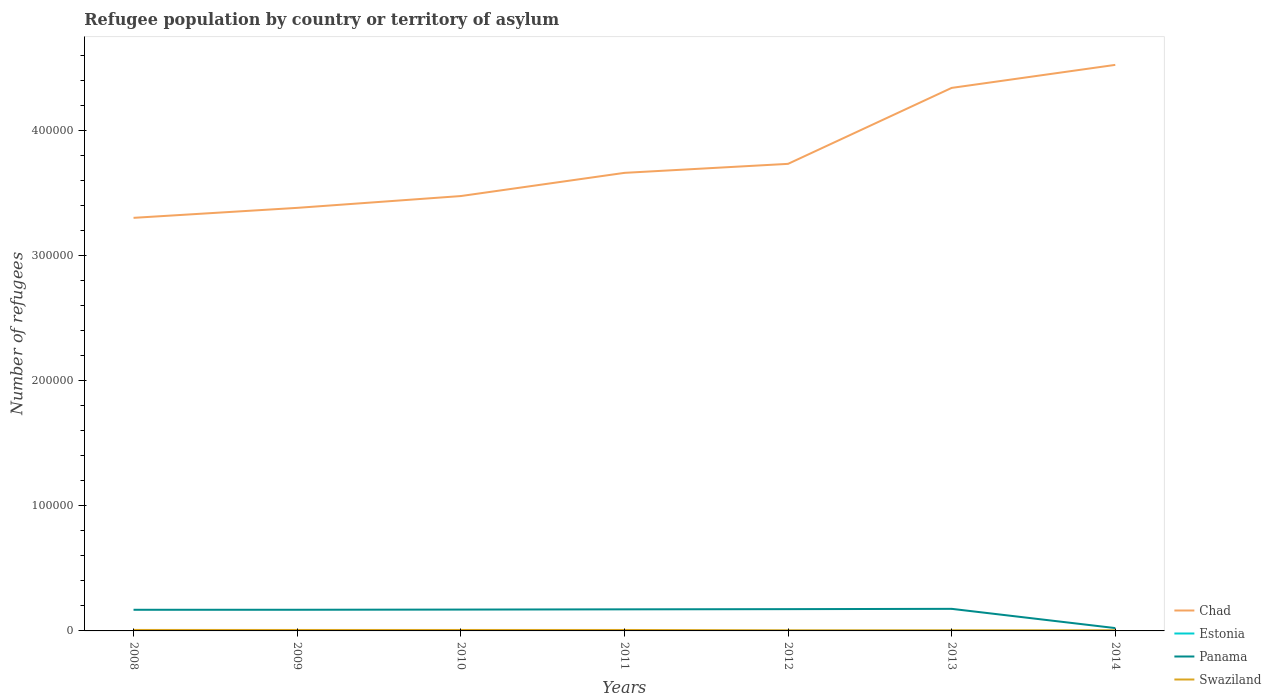How many different coloured lines are there?
Your answer should be compact. 4. What is the total number of refugees in Panama in the graph?
Give a very brief answer. 1.52e+04. What is the difference between the highest and the second highest number of refugees in Swaziland?
Your answer should be very brief. 270. What is the difference between the highest and the lowest number of refugees in Estonia?
Give a very brief answer. 3. Is the number of refugees in Swaziland strictly greater than the number of refugees in Chad over the years?
Give a very brief answer. Yes. How many lines are there?
Keep it short and to the point. 4. How many years are there in the graph?
Keep it short and to the point. 7. What is the difference between two consecutive major ticks on the Y-axis?
Keep it short and to the point. 1.00e+05. What is the title of the graph?
Give a very brief answer. Refugee population by country or territory of asylum. Does "Indonesia" appear as one of the legend labels in the graph?
Your answer should be very brief. No. What is the label or title of the Y-axis?
Your response must be concise. Number of refugees. What is the Number of refugees of Chad in 2008?
Make the answer very short. 3.31e+05. What is the Number of refugees of Panama in 2008?
Provide a succinct answer. 1.69e+04. What is the Number of refugees in Swaziland in 2008?
Give a very brief answer. 775. What is the Number of refugees in Chad in 2009?
Provide a short and direct response. 3.38e+05. What is the Number of refugees in Panama in 2009?
Your response must be concise. 1.69e+04. What is the Number of refugees in Swaziland in 2009?
Ensure brevity in your answer.  759. What is the Number of refugees in Chad in 2010?
Your answer should be compact. 3.48e+05. What is the Number of refugees of Estonia in 2010?
Your answer should be compact. 39. What is the Number of refugees in Panama in 2010?
Offer a terse response. 1.71e+04. What is the Number of refugees of Swaziland in 2010?
Make the answer very short. 759. What is the Number of refugees in Chad in 2011?
Make the answer very short. 3.66e+05. What is the Number of refugees in Estonia in 2011?
Give a very brief answer. 50. What is the Number of refugees in Panama in 2011?
Your answer should be very brief. 1.73e+04. What is the Number of refugees of Swaziland in 2011?
Your answer should be compact. 759. What is the Number of refugees of Chad in 2012?
Provide a succinct answer. 3.74e+05. What is the Number of refugees in Estonia in 2012?
Your answer should be compact. 63. What is the Number of refugees in Panama in 2012?
Ensure brevity in your answer.  1.74e+04. What is the Number of refugees of Swaziland in 2012?
Provide a succinct answer. 505. What is the Number of refugees of Chad in 2013?
Offer a terse response. 4.34e+05. What is the Number of refugees of Estonia in 2013?
Give a very brief answer. 70. What is the Number of refugees of Panama in 2013?
Give a very brief answer. 1.77e+04. What is the Number of refugees in Swaziland in 2013?
Your response must be concise. 507. What is the Number of refugees in Chad in 2014?
Ensure brevity in your answer.  4.53e+05. What is the Number of refugees of Estonia in 2014?
Keep it short and to the point. 90. What is the Number of refugees of Panama in 2014?
Provide a succinct answer. 2271. What is the Number of refugees in Swaziland in 2014?
Make the answer very short. 515. Across all years, what is the maximum Number of refugees in Chad?
Provide a succinct answer. 4.53e+05. Across all years, what is the maximum Number of refugees in Panama?
Your answer should be very brief. 1.77e+04. Across all years, what is the maximum Number of refugees of Swaziland?
Keep it short and to the point. 775. Across all years, what is the minimum Number of refugees of Chad?
Give a very brief answer. 3.31e+05. Across all years, what is the minimum Number of refugees of Panama?
Your answer should be very brief. 2271. Across all years, what is the minimum Number of refugees of Swaziland?
Give a very brief answer. 505. What is the total Number of refugees of Chad in the graph?
Keep it short and to the point. 2.64e+06. What is the total Number of refugees of Estonia in the graph?
Offer a very short reply. 358. What is the total Number of refugees in Panama in the graph?
Provide a succinct answer. 1.06e+05. What is the total Number of refugees of Swaziland in the graph?
Make the answer very short. 4579. What is the difference between the Number of refugees of Chad in 2008 and that in 2009?
Your answer should be very brief. -7985. What is the difference between the Number of refugees of Estonia in 2008 and that in 2009?
Ensure brevity in your answer.  -2. What is the difference between the Number of refugees of Panama in 2008 and that in 2009?
Ensure brevity in your answer.  -10. What is the difference between the Number of refugees in Chad in 2008 and that in 2010?
Offer a terse response. -1.74e+04. What is the difference between the Number of refugees of Estonia in 2008 and that in 2010?
Your response must be concise. -17. What is the difference between the Number of refugees in Panama in 2008 and that in 2010?
Keep it short and to the point. -160. What is the difference between the Number of refugees in Chad in 2008 and that in 2011?
Your answer should be very brief. -3.60e+04. What is the difference between the Number of refugees of Estonia in 2008 and that in 2011?
Give a very brief answer. -28. What is the difference between the Number of refugees in Panama in 2008 and that in 2011?
Offer a very short reply. -349. What is the difference between the Number of refugees in Swaziland in 2008 and that in 2011?
Make the answer very short. 16. What is the difference between the Number of refugees in Chad in 2008 and that in 2012?
Your response must be concise. -4.32e+04. What is the difference between the Number of refugees of Estonia in 2008 and that in 2012?
Make the answer very short. -41. What is the difference between the Number of refugees in Panama in 2008 and that in 2012?
Your response must be concise. -516. What is the difference between the Number of refugees in Swaziland in 2008 and that in 2012?
Offer a terse response. 270. What is the difference between the Number of refugees of Chad in 2008 and that in 2013?
Provide a succinct answer. -1.04e+05. What is the difference between the Number of refugees in Estonia in 2008 and that in 2013?
Keep it short and to the point. -48. What is the difference between the Number of refugees in Panama in 2008 and that in 2013?
Keep it short and to the point. -752. What is the difference between the Number of refugees of Swaziland in 2008 and that in 2013?
Offer a very short reply. 268. What is the difference between the Number of refugees of Chad in 2008 and that in 2014?
Offer a very short reply. -1.22e+05. What is the difference between the Number of refugees in Estonia in 2008 and that in 2014?
Provide a short and direct response. -68. What is the difference between the Number of refugees of Panama in 2008 and that in 2014?
Provide a succinct answer. 1.46e+04. What is the difference between the Number of refugees of Swaziland in 2008 and that in 2014?
Provide a succinct answer. 260. What is the difference between the Number of refugees of Chad in 2009 and that in 2010?
Provide a short and direct response. -9444. What is the difference between the Number of refugees in Estonia in 2009 and that in 2010?
Provide a short and direct response. -15. What is the difference between the Number of refugees of Panama in 2009 and that in 2010?
Provide a succinct answer. -150. What is the difference between the Number of refugees in Swaziland in 2009 and that in 2010?
Keep it short and to the point. 0. What is the difference between the Number of refugees in Chad in 2009 and that in 2011?
Provide a short and direct response. -2.80e+04. What is the difference between the Number of refugees of Panama in 2009 and that in 2011?
Provide a short and direct response. -339. What is the difference between the Number of refugees in Chad in 2009 and that in 2012?
Offer a very short reply. -3.52e+04. What is the difference between the Number of refugees of Estonia in 2009 and that in 2012?
Provide a succinct answer. -39. What is the difference between the Number of refugees in Panama in 2009 and that in 2012?
Provide a succinct answer. -506. What is the difference between the Number of refugees of Swaziland in 2009 and that in 2012?
Ensure brevity in your answer.  254. What is the difference between the Number of refugees of Chad in 2009 and that in 2013?
Make the answer very short. -9.60e+04. What is the difference between the Number of refugees of Estonia in 2009 and that in 2013?
Your answer should be very brief. -46. What is the difference between the Number of refugees in Panama in 2009 and that in 2013?
Provide a short and direct response. -742. What is the difference between the Number of refugees of Swaziland in 2009 and that in 2013?
Your response must be concise. 252. What is the difference between the Number of refugees in Chad in 2009 and that in 2014?
Make the answer very short. -1.14e+05. What is the difference between the Number of refugees of Estonia in 2009 and that in 2014?
Your response must be concise. -66. What is the difference between the Number of refugees in Panama in 2009 and that in 2014?
Your response must be concise. 1.47e+04. What is the difference between the Number of refugees of Swaziland in 2009 and that in 2014?
Your answer should be compact. 244. What is the difference between the Number of refugees of Chad in 2010 and that in 2011?
Your answer should be very brief. -1.86e+04. What is the difference between the Number of refugees in Estonia in 2010 and that in 2011?
Ensure brevity in your answer.  -11. What is the difference between the Number of refugees of Panama in 2010 and that in 2011?
Your answer should be very brief. -189. What is the difference between the Number of refugees in Chad in 2010 and that in 2012?
Keep it short and to the point. -2.58e+04. What is the difference between the Number of refugees of Estonia in 2010 and that in 2012?
Your answer should be compact. -24. What is the difference between the Number of refugees in Panama in 2010 and that in 2012?
Provide a succinct answer. -356. What is the difference between the Number of refugees of Swaziland in 2010 and that in 2012?
Provide a short and direct response. 254. What is the difference between the Number of refugees of Chad in 2010 and that in 2013?
Give a very brief answer. -8.65e+04. What is the difference between the Number of refugees in Estonia in 2010 and that in 2013?
Your response must be concise. -31. What is the difference between the Number of refugees in Panama in 2010 and that in 2013?
Your answer should be very brief. -592. What is the difference between the Number of refugees in Swaziland in 2010 and that in 2013?
Make the answer very short. 252. What is the difference between the Number of refugees in Chad in 2010 and that in 2014?
Provide a short and direct response. -1.05e+05. What is the difference between the Number of refugees of Estonia in 2010 and that in 2014?
Your answer should be very brief. -51. What is the difference between the Number of refugees in Panama in 2010 and that in 2014?
Make the answer very short. 1.48e+04. What is the difference between the Number of refugees in Swaziland in 2010 and that in 2014?
Provide a succinct answer. 244. What is the difference between the Number of refugees in Chad in 2011 and that in 2012?
Offer a very short reply. -7201. What is the difference between the Number of refugees of Panama in 2011 and that in 2012?
Your answer should be compact. -167. What is the difference between the Number of refugees of Swaziland in 2011 and that in 2012?
Ensure brevity in your answer.  254. What is the difference between the Number of refugees in Chad in 2011 and that in 2013?
Make the answer very short. -6.80e+04. What is the difference between the Number of refugees in Estonia in 2011 and that in 2013?
Provide a short and direct response. -20. What is the difference between the Number of refugees of Panama in 2011 and that in 2013?
Keep it short and to the point. -403. What is the difference between the Number of refugees of Swaziland in 2011 and that in 2013?
Give a very brief answer. 252. What is the difference between the Number of refugees of Chad in 2011 and that in 2014?
Ensure brevity in your answer.  -8.64e+04. What is the difference between the Number of refugees in Panama in 2011 and that in 2014?
Ensure brevity in your answer.  1.50e+04. What is the difference between the Number of refugees of Swaziland in 2011 and that in 2014?
Your answer should be very brief. 244. What is the difference between the Number of refugees in Chad in 2012 and that in 2013?
Keep it short and to the point. -6.08e+04. What is the difference between the Number of refugees of Estonia in 2012 and that in 2013?
Give a very brief answer. -7. What is the difference between the Number of refugees in Panama in 2012 and that in 2013?
Ensure brevity in your answer.  -236. What is the difference between the Number of refugees of Chad in 2012 and that in 2014?
Keep it short and to the point. -7.92e+04. What is the difference between the Number of refugees of Estonia in 2012 and that in 2014?
Make the answer very short. -27. What is the difference between the Number of refugees of Panama in 2012 and that in 2014?
Keep it short and to the point. 1.52e+04. What is the difference between the Number of refugees of Chad in 2013 and that in 2014?
Keep it short and to the point. -1.84e+04. What is the difference between the Number of refugees of Estonia in 2013 and that in 2014?
Your response must be concise. -20. What is the difference between the Number of refugees in Panama in 2013 and that in 2014?
Provide a short and direct response. 1.54e+04. What is the difference between the Number of refugees of Swaziland in 2013 and that in 2014?
Provide a succinct answer. -8. What is the difference between the Number of refugees of Chad in 2008 and the Number of refugees of Estonia in 2009?
Offer a very short reply. 3.30e+05. What is the difference between the Number of refugees of Chad in 2008 and the Number of refugees of Panama in 2009?
Keep it short and to the point. 3.14e+05. What is the difference between the Number of refugees of Chad in 2008 and the Number of refugees of Swaziland in 2009?
Provide a succinct answer. 3.30e+05. What is the difference between the Number of refugees in Estonia in 2008 and the Number of refugees in Panama in 2009?
Provide a short and direct response. -1.69e+04. What is the difference between the Number of refugees of Estonia in 2008 and the Number of refugees of Swaziland in 2009?
Ensure brevity in your answer.  -737. What is the difference between the Number of refugees in Panama in 2008 and the Number of refugees in Swaziland in 2009?
Make the answer very short. 1.62e+04. What is the difference between the Number of refugees in Chad in 2008 and the Number of refugees in Estonia in 2010?
Make the answer very short. 3.30e+05. What is the difference between the Number of refugees in Chad in 2008 and the Number of refugees in Panama in 2010?
Your answer should be very brief. 3.13e+05. What is the difference between the Number of refugees of Chad in 2008 and the Number of refugees of Swaziland in 2010?
Make the answer very short. 3.30e+05. What is the difference between the Number of refugees in Estonia in 2008 and the Number of refugees in Panama in 2010?
Your answer should be very brief. -1.71e+04. What is the difference between the Number of refugees of Estonia in 2008 and the Number of refugees of Swaziland in 2010?
Ensure brevity in your answer.  -737. What is the difference between the Number of refugees of Panama in 2008 and the Number of refugees of Swaziland in 2010?
Give a very brief answer. 1.62e+04. What is the difference between the Number of refugees in Chad in 2008 and the Number of refugees in Estonia in 2011?
Offer a terse response. 3.30e+05. What is the difference between the Number of refugees of Chad in 2008 and the Number of refugees of Panama in 2011?
Provide a succinct answer. 3.13e+05. What is the difference between the Number of refugees in Chad in 2008 and the Number of refugees in Swaziland in 2011?
Provide a short and direct response. 3.30e+05. What is the difference between the Number of refugees in Estonia in 2008 and the Number of refugees in Panama in 2011?
Your answer should be compact. -1.72e+04. What is the difference between the Number of refugees of Estonia in 2008 and the Number of refugees of Swaziland in 2011?
Give a very brief answer. -737. What is the difference between the Number of refugees of Panama in 2008 and the Number of refugees of Swaziland in 2011?
Provide a short and direct response. 1.62e+04. What is the difference between the Number of refugees in Chad in 2008 and the Number of refugees in Estonia in 2012?
Your response must be concise. 3.30e+05. What is the difference between the Number of refugees in Chad in 2008 and the Number of refugees in Panama in 2012?
Your answer should be very brief. 3.13e+05. What is the difference between the Number of refugees in Chad in 2008 and the Number of refugees in Swaziland in 2012?
Offer a very short reply. 3.30e+05. What is the difference between the Number of refugees of Estonia in 2008 and the Number of refugees of Panama in 2012?
Provide a succinct answer. -1.74e+04. What is the difference between the Number of refugees of Estonia in 2008 and the Number of refugees of Swaziland in 2012?
Ensure brevity in your answer.  -483. What is the difference between the Number of refugees in Panama in 2008 and the Number of refugees in Swaziland in 2012?
Your answer should be compact. 1.64e+04. What is the difference between the Number of refugees of Chad in 2008 and the Number of refugees of Estonia in 2013?
Provide a succinct answer. 3.30e+05. What is the difference between the Number of refugees in Chad in 2008 and the Number of refugees in Panama in 2013?
Your answer should be compact. 3.13e+05. What is the difference between the Number of refugees in Chad in 2008 and the Number of refugees in Swaziland in 2013?
Keep it short and to the point. 3.30e+05. What is the difference between the Number of refugees of Estonia in 2008 and the Number of refugees of Panama in 2013?
Keep it short and to the point. -1.76e+04. What is the difference between the Number of refugees in Estonia in 2008 and the Number of refugees in Swaziland in 2013?
Your answer should be compact. -485. What is the difference between the Number of refugees in Panama in 2008 and the Number of refugees in Swaziland in 2013?
Your response must be concise. 1.64e+04. What is the difference between the Number of refugees of Chad in 2008 and the Number of refugees of Estonia in 2014?
Your answer should be very brief. 3.30e+05. What is the difference between the Number of refugees in Chad in 2008 and the Number of refugees in Panama in 2014?
Ensure brevity in your answer.  3.28e+05. What is the difference between the Number of refugees of Chad in 2008 and the Number of refugees of Swaziland in 2014?
Provide a succinct answer. 3.30e+05. What is the difference between the Number of refugees in Estonia in 2008 and the Number of refugees in Panama in 2014?
Keep it short and to the point. -2249. What is the difference between the Number of refugees in Estonia in 2008 and the Number of refugees in Swaziland in 2014?
Make the answer very short. -493. What is the difference between the Number of refugees in Panama in 2008 and the Number of refugees in Swaziland in 2014?
Your answer should be very brief. 1.64e+04. What is the difference between the Number of refugees of Chad in 2009 and the Number of refugees of Estonia in 2010?
Offer a terse response. 3.38e+05. What is the difference between the Number of refugees in Chad in 2009 and the Number of refugees in Panama in 2010?
Keep it short and to the point. 3.21e+05. What is the difference between the Number of refugees in Chad in 2009 and the Number of refugees in Swaziland in 2010?
Provide a short and direct response. 3.38e+05. What is the difference between the Number of refugees in Estonia in 2009 and the Number of refugees in Panama in 2010?
Offer a terse response. -1.70e+04. What is the difference between the Number of refugees in Estonia in 2009 and the Number of refugees in Swaziland in 2010?
Offer a very short reply. -735. What is the difference between the Number of refugees of Panama in 2009 and the Number of refugees of Swaziland in 2010?
Provide a short and direct response. 1.62e+04. What is the difference between the Number of refugees in Chad in 2009 and the Number of refugees in Estonia in 2011?
Ensure brevity in your answer.  3.38e+05. What is the difference between the Number of refugees of Chad in 2009 and the Number of refugees of Panama in 2011?
Offer a very short reply. 3.21e+05. What is the difference between the Number of refugees in Chad in 2009 and the Number of refugees in Swaziland in 2011?
Provide a succinct answer. 3.38e+05. What is the difference between the Number of refugees of Estonia in 2009 and the Number of refugees of Panama in 2011?
Offer a very short reply. -1.72e+04. What is the difference between the Number of refugees in Estonia in 2009 and the Number of refugees in Swaziland in 2011?
Provide a short and direct response. -735. What is the difference between the Number of refugees in Panama in 2009 and the Number of refugees in Swaziland in 2011?
Give a very brief answer. 1.62e+04. What is the difference between the Number of refugees of Chad in 2009 and the Number of refugees of Estonia in 2012?
Provide a short and direct response. 3.38e+05. What is the difference between the Number of refugees of Chad in 2009 and the Number of refugees of Panama in 2012?
Keep it short and to the point. 3.21e+05. What is the difference between the Number of refugees in Chad in 2009 and the Number of refugees in Swaziland in 2012?
Ensure brevity in your answer.  3.38e+05. What is the difference between the Number of refugees in Estonia in 2009 and the Number of refugees in Panama in 2012?
Ensure brevity in your answer.  -1.74e+04. What is the difference between the Number of refugees in Estonia in 2009 and the Number of refugees in Swaziland in 2012?
Your answer should be very brief. -481. What is the difference between the Number of refugees of Panama in 2009 and the Number of refugees of Swaziland in 2012?
Make the answer very short. 1.64e+04. What is the difference between the Number of refugees in Chad in 2009 and the Number of refugees in Estonia in 2013?
Your answer should be very brief. 3.38e+05. What is the difference between the Number of refugees in Chad in 2009 and the Number of refugees in Panama in 2013?
Your answer should be compact. 3.21e+05. What is the difference between the Number of refugees in Chad in 2009 and the Number of refugees in Swaziland in 2013?
Keep it short and to the point. 3.38e+05. What is the difference between the Number of refugees in Estonia in 2009 and the Number of refugees in Panama in 2013?
Ensure brevity in your answer.  -1.76e+04. What is the difference between the Number of refugees in Estonia in 2009 and the Number of refugees in Swaziland in 2013?
Give a very brief answer. -483. What is the difference between the Number of refugees of Panama in 2009 and the Number of refugees of Swaziland in 2013?
Offer a terse response. 1.64e+04. What is the difference between the Number of refugees of Chad in 2009 and the Number of refugees of Estonia in 2014?
Provide a short and direct response. 3.38e+05. What is the difference between the Number of refugees of Chad in 2009 and the Number of refugees of Panama in 2014?
Make the answer very short. 3.36e+05. What is the difference between the Number of refugees of Chad in 2009 and the Number of refugees of Swaziland in 2014?
Ensure brevity in your answer.  3.38e+05. What is the difference between the Number of refugees of Estonia in 2009 and the Number of refugees of Panama in 2014?
Your answer should be very brief. -2247. What is the difference between the Number of refugees in Estonia in 2009 and the Number of refugees in Swaziland in 2014?
Keep it short and to the point. -491. What is the difference between the Number of refugees in Panama in 2009 and the Number of refugees in Swaziland in 2014?
Your answer should be very brief. 1.64e+04. What is the difference between the Number of refugees of Chad in 2010 and the Number of refugees of Estonia in 2011?
Your response must be concise. 3.48e+05. What is the difference between the Number of refugees of Chad in 2010 and the Number of refugees of Panama in 2011?
Offer a terse response. 3.31e+05. What is the difference between the Number of refugees of Chad in 2010 and the Number of refugees of Swaziland in 2011?
Make the answer very short. 3.47e+05. What is the difference between the Number of refugees in Estonia in 2010 and the Number of refugees in Panama in 2011?
Offer a very short reply. -1.72e+04. What is the difference between the Number of refugees in Estonia in 2010 and the Number of refugees in Swaziland in 2011?
Offer a terse response. -720. What is the difference between the Number of refugees in Panama in 2010 and the Number of refugees in Swaziland in 2011?
Offer a very short reply. 1.63e+04. What is the difference between the Number of refugees of Chad in 2010 and the Number of refugees of Estonia in 2012?
Provide a succinct answer. 3.48e+05. What is the difference between the Number of refugees of Chad in 2010 and the Number of refugees of Panama in 2012?
Make the answer very short. 3.31e+05. What is the difference between the Number of refugees in Chad in 2010 and the Number of refugees in Swaziland in 2012?
Ensure brevity in your answer.  3.47e+05. What is the difference between the Number of refugees in Estonia in 2010 and the Number of refugees in Panama in 2012?
Offer a terse response. -1.74e+04. What is the difference between the Number of refugees of Estonia in 2010 and the Number of refugees of Swaziland in 2012?
Your answer should be very brief. -466. What is the difference between the Number of refugees in Panama in 2010 and the Number of refugees in Swaziland in 2012?
Offer a terse response. 1.66e+04. What is the difference between the Number of refugees in Chad in 2010 and the Number of refugees in Estonia in 2013?
Give a very brief answer. 3.48e+05. What is the difference between the Number of refugees in Chad in 2010 and the Number of refugees in Panama in 2013?
Provide a short and direct response. 3.30e+05. What is the difference between the Number of refugees of Chad in 2010 and the Number of refugees of Swaziland in 2013?
Your answer should be very brief. 3.47e+05. What is the difference between the Number of refugees of Estonia in 2010 and the Number of refugees of Panama in 2013?
Provide a short and direct response. -1.76e+04. What is the difference between the Number of refugees of Estonia in 2010 and the Number of refugees of Swaziland in 2013?
Your response must be concise. -468. What is the difference between the Number of refugees of Panama in 2010 and the Number of refugees of Swaziland in 2013?
Provide a succinct answer. 1.66e+04. What is the difference between the Number of refugees in Chad in 2010 and the Number of refugees in Estonia in 2014?
Ensure brevity in your answer.  3.48e+05. What is the difference between the Number of refugees in Chad in 2010 and the Number of refugees in Panama in 2014?
Provide a short and direct response. 3.46e+05. What is the difference between the Number of refugees in Chad in 2010 and the Number of refugees in Swaziland in 2014?
Your response must be concise. 3.47e+05. What is the difference between the Number of refugees in Estonia in 2010 and the Number of refugees in Panama in 2014?
Provide a short and direct response. -2232. What is the difference between the Number of refugees of Estonia in 2010 and the Number of refugees of Swaziland in 2014?
Your answer should be very brief. -476. What is the difference between the Number of refugees in Panama in 2010 and the Number of refugees in Swaziland in 2014?
Your answer should be compact. 1.66e+04. What is the difference between the Number of refugees in Chad in 2011 and the Number of refugees in Estonia in 2012?
Your response must be concise. 3.66e+05. What is the difference between the Number of refugees of Chad in 2011 and the Number of refugees of Panama in 2012?
Provide a short and direct response. 3.49e+05. What is the difference between the Number of refugees in Chad in 2011 and the Number of refugees in Swaziland in 2012?
Offer a terse response. 3.66e+05. What is the difference between the Number of refugees in Estonia in 2011 and the Number of refugees in Panama in 2012?
Your response must be concise. -1.74e+04. What is the difference between the Number of refugees in Estonia in 2011 and the Number of refugees in Swaziland in 2012?
Provide a succinct answer. -455. What is the difference between the Number of refugees of Panama in 2011 and the Number of refugees of Swaziland in 2012?
Give a very brief answer. 1.68e+04. What is the difference between the Number of refugees of Chad in 2011 and the Number of refugees of Estonia in 2013?
Keep it short and to the point. 3.66e+05. What is the difference between the Number of refugees in Chad in 2011 and the Number of refugees in Panama in 2013?
Provide a succinct answer. 3.49e+05. What is the difference between the Number of refugees of Chad in 2011 and the Number of refugees of Swaziland in 2013?
Give a very brief answer. 3.66e+05. What is the difference between the Number of refugees of Estonia in 2011 and the Number of refugees of Panama in 2013?
Your answer should be compact. -1.76e+04. What is the difference between the Number of refugees in Estonia in 2011 and the Number of refugees in Swaziland in 2013?
Ensure brevity in your answer.  -457. What is the difference between the Number of refugees in Panama in 2011 and the Number of refugees in Swaziland in 2013?
Your response must be concise. 1.68e+04. What is the difference between the Number of refugees in Chad in 2011 and the Number of refugees in Estonia in 2014?
Make the answer very short. 3.66e+05. What is the difference between the Number of refugees of Chad in 2011 and the Number of refugees of Panama in 2014?
Provide a succinct answer. 3.64e+05. What is the difference between the Number of refugees of Chad in 2011 and the Number of refugees of Swaziland in 2014?
Make the answer very short. 3.66e+05. What is the difference between the Number of refugees in Estonia in 2011 and the Number of refugees in Panama in 2014?
Offer a terse response. -2221. What is the difference between the Number of refugees of Estonia in 2011 and the Number of refugees of Swaziland in 2014?
Make the answer very short. -465. What is the difference between the Number of refugees in Panama in 2011 and the Number of refugees in Swaziland in 2014?
Offer a terse response. 1.67e+04. What is the difference between the Number of refugees in Chad in 2012 and the Number of refugees in Estonia in 2013?
Provide a short and direct response. 3.74e+05. What is the difference between the Number of refugees of Chad in 2012 and the Number of refugees of Panama in 2013?
Provide a short and direct response. 3.56e+05. What is the difference between the Number of refugees in Chad in 2012 and the Number of refugees in Swaziland in 2013?
Offer a terse response. 3.73e+05. What is the difference between the Number of refugees of Estonia in 2012 and the Number of refugees of Panama in 2013?
Keep it short and to the point. -1.76e+04. What is the difference between the Number of refugees of Estonia in 2012 and the Number of refugees of Swaziland in 2013?
Ensure brevity in your answer.  -444. What is the difference between the Number of refugees of Panama in 2012 and the Number of refugees of Swaziland in 2013?
Ensure brevity in your answer.  1.69e+04. What is the difference between the Number of refugees of Chad in 2012 and the Number of refugees of Estonia in 2014?
Your response must be concise. 3.74e+05. What is the difference between the Number of refugees in Chad in 2012 and the Number of refugees in Panama in 2014?
Provide a short and direct response. 3.71e+05. What is the difference between the Number of refugees of Chad in 2012 and the Number of refugees of Swaziland in 2014?
Your answer should be very brief. 3.73e+05. What is the difference between the Number of refugees of Estonia in 2012 and the Number of refugees of Panama in 2014?
Offer a terse response. -2208. What is the difference between the Number of refugees in Estonia in 2012 and the Number of refugees in Swaziland in 2014?
Your response must be concise. -452. What is the difference between the Number of refugees of Panama in 2012 and the Number of refugees of Swaziland in 2014?
Make the answer very short. 1.69e+04. What is the difference between the Number of refugees of Chad in 2013 and the Number of refugees of Estonia in 2014?
Offer a terse response. 4.34e+05. What is the difference between the Number of refugees in Chad in 2013 and the Number of refugees in Panama in 2014?
Ensure brevity in your answer.  4.32e+05. What is the difference between the Number of refugees in Chad in 2013 and the Number of refugees in Swaziland in 2014?
Make the answer very short. 4.34e+05. What is the difference between the Number of refugees of Estonia in 2013 and the Number of refugees of Panama in 2014?
Provide a short and direct response. -2201. What is the difference between the Number of refugees of Estonia in 2013 and the Number of refugees of Swaziland in 2014?
Your answer should be compact. -445. What is the difference between the Number of refugees of Panama in 2013 and the Number of refugees of Swaziland in 2014?
Your answer should be very brief. 1.72e+04. What is the average Number of refugees of Chad per year?
Ensure brevity in your answer.  3.78e+05. What is the average Number of refugees of Estonia per year?
Provide a succinct answer. 51.14. What is the average Number of refugees in Panama per year?
Your answer should be very brief. 1.51e+04. What is the average Number of refugees in Swaziland per year?
Provide a short and direct response. 654.14. In the year 2008, what is the difference between the Number of refugees in Chad and Number of refugees in Estonia?
Give a very brief answer. 3.30e+05. In the year 2008, what is the difference between the Number of refugees in Chad and Number of refugees in Panama?
Provide a succinct answer. 3.14e+05. In the year 2008, what is the difference between the Number of refugees of Chad and Number of refugees of Swaziland?
Ensure brevity in your answer.  3.30e+05. In the year 2008, what is the difference between the Number of refugees in Estonia and Number of refugees in Panama?
Make the answer very short. -1.69e+04. In the year 2008, what is the difference between the Number of refugees in Estonia and Number of refugees in Swaziland?
Give a very brief answer. -753. In the year 2008, what is the difference between the Number of refugees in Panama and Number of refugees in Swaziland?
Offer a terse response. 1.61e+04. In the year 2009, what is the difference between the Number of refugees of Chad and Number of refugees of Estonia?
Offer a terse response. 3.38e+05. In the year 2009, what is the difference between the Number of refugees in Chad and Number of refugees in Panama?
Give a very brief answer. 3.22e+05. In the year 2009, what is the difference between the Number of refugees in Chad and Number of refugees in Swaziland?
Your response must be concise. 3.38e+05. In the year 2009, what is the difference between the Number of refugees in Estonia and Number of refugees in Panama?
Make the answer very short. -1.69e+04. In the year 2009, what is the difference between the Number of refugees of Estonia and Number of refugees of Swaziland?
Offer a very short reply. -735. In the year 2009, what is the difference between the Number of refugees in Panama and Number of refugees in Swaziland?
Offer a very short reply. 1.62e+04. In the year 2010, what is the difference between the Number of refugees of Chad and Number of refugees of Estonia?
Your answer should be very brief. 3.48e+05. In the year 2010, what is the difference between the Number of refugees of Chad and Number of refugees of Panama?
Provide a succinct answer. 3.31e+05. In the year 2010, what is the difference between the Number of refugees in Chad and Number of refugees in Swaziland?
Ensure brevity in your answer.  3.47e+05. In the year 2010, what is the difference between the Number of refugees in Estonia and Number of refugees in Panama?
Keep it short and to the point. -1.70e+04. In the year 2010, what is the difference between the Number of refugees in Estonia and Number of refugees in Swaziland?
Your answer should be compact. -720. In the year 2010, what is the difference between the Number of refugees of Panama and Number of refugees of Swaziland?
Offer a very short reply. 1.63e+04. In the year 2011, what is the difference between the Number of refugees of Chad and Number of refugees of Estonia?
Give a very brief answer. 3.66e+05. In the year 2011, what is the difference between the Number of refugees in Chad and Number of refugees in Panama?
Provide a short and direct response. 3.49e+05. In the year 2011, what is the difference between the Number of refugees in Chad and Number of refugees in Swaziland?
Provide a succinct answer. 3.66e+05. In the year 2011, what is the difference between the Number of refugees in Estonia and Number of refugees in Panama?
Offer a very short reply. -1.72e+04. In the year 2011, what is the difference between the Number of refugees in Estonia and Number of refugees in Swaziland?
Your response must be concise. -709. In the year 2011, what is the difference between the Number of refugees of Panama and Number of refugees of Swaziland?
Keep it short and to the point. 1.65e+04. In the year 2012, what is the difference between the Number of refugees of Chad and Number of refugees of Estonia?
Your response must be concise. 3.74e+05. In the year 2012, what is the difference between the Number of refugees of Chad and Number of refugees of Panama?
Provide a succinct answer. 3.56e+05. In the year 2012, what is the difference between the Number of refugees in Chad and Number of refugees in Swaziland?
Provide a short and direct response. 3.73e+05. In the year 2012, what is the difference between the Number of refugees of Estonia and Number of refugees of Panama?
Give a very brief answer. -1.74e+04. In the year 2012, what is the difference between the Number of refugees in Estonia and Number of refugees in Swaziland?
Provide a short and direct response. -442. In the year 2012, what is the difference between the Number of refugees of Panama and Number of refugees of Swaziland?
Provide a short and direct response. 1.69e+04. In the year 2013, what is the difference between the Number of refugees of Chad and Number of refugees of Estonia?
Provide a succinct answer. 4.34e+05. In the year 2013, what is the difference between the Number of refugees in Chad and Number of refugees in Panama?
Your answer should be very brief. 4.17e+05. In the year 2013, what is the difference between the Number of refugees of Chad and Number of refugees of Swaziland?
Keep it short and to the point. 4.34e+05. In the year 2013, what is the difference between the Number of refugees in Estonia and Number of refugees in Panama?
Provide a succinct answer. -1.76e+04. In the year 2013, what is the difference between the Number of refugees of Estonia and Number of refugees of Swaziland?
Ensure brevity in your answer.  -437. In the year 2013, what is the difference between the Number of refugees in Panama and Number of refugees in Swaziland?
Offer a terse response. 1.72e+04. In the year 2014, what is the difference between the Number of refugees in Chad and Number of refugees in Estonia?
Provide a succinct answer. 4.53e+05. In the year 2014, what is the difference between the Number of refugees of Chad and Number of refugees of Panama?
Ensure brevity in your answer.  4.51e+05. In the year 2014, what is the difference between the Number of refugees in Chad and Number of refugees in Swaziland?
Provide a short and direct response. 4.52e+05. In the year 2014, what is the difference between the Number of refugees of Estonia and Number of refugees of Panama?
Offer a terse response. -2181. In the year 2014, what is the difference between the Number of refugees of Estonia and Number of refugees of Swaziland?
Give a very brief answer. -425. In the year 2014, what is the difference between the Number of refugees in Panama and Number of refugees in Swaziland?
Offer a very short reply. 1756. What is the ratio of the Number of refugees of Chad in 2008 to that in 2009?
Offer a very short reply. 0.98. What is the ratio of the Number of refugees of Estonia in 2008 to that in 2009?
Provide a succinct answer. 0.92. What is the ratio of the Number of refugees in Swaziland in 2008 to that in 2009?
Ensure brevity in your answer.  1.02. What is the ratio of the Number of refugees of Chad in 2008 to that in 2010?
Keep it short and to the point. 0.95. What is the ratio of the Number of refugees in Estonia in 2008 to that in 2010?
Your answer should be compact. 0.56. What is the ratio of the Number of refugees in Panama in 2008 to that in 2010?
Your response must be concise. 0.99. What is the ratio of the Number of refugees in Swaziland in 2008 to that in 2010?
Make the answer very short. 1.02. What is the ratio of the Number of refugees of Chad in 2008 to that in 2011?
Keep it short and to the point. 0.9. What is the ratio of the Number of refugees of Estonia in 2008 to that in 2011?
Your answer should be compact. 0.44. What is the ratio of the Number of refugees of Panama in 2008 to that in 2011?
Your answer should be very brief. 0.98. What is the ratio of the Number of refugees of Swaziland in 2008 to that in 2011?
Ensure brevity in your answer.  1.02. What is the ratio of the Number of refugees of Chad in 2008 to that in 2012?
Provide a succinct answer. 0.88. What is the ratio of the Number of refugees in Estonia in 2008 to that in 2012?
Make the answer very short. 0.35. What is the ratio of the Number of refugees of Panama in 2008 to that in 2012?
Give a very brief answer. 0.97. What is the ratio of the Number of refugees of Swaziland in 2008 to that in 2012?
Offer a terse response. 1.53. What is the ratio of the Number of refugees of Chad in 2008 to that in 2013?
Ensure brevity in your answer.  0.76. What is the ratio of the Number of refugees of Estonia in 2008 to that in 2013?
Keep it short and to the point. 0.31. What is the ratio of the Number of refugees of Panama in 2008 to that in 2013?
Offer a very short reply. 0.96. What is the ratio of the Number of refugees in Swaziland in 2008 to that in 2013?
Provide a short and direct response. 1.53. What is the ratio of the Number of refugees of Chad in 2008 to that in 2014?
Offer a very short reply. 0.73. What is the ratio of the Number of refugees in Estonia in 2008 to that in 2014?
Your answer should be very brief. 0.24. What is the ratio of the Number of refugees of Panama in 2008 to that in 2014?
Provide a short and direct response. 7.45. What is the ratio of the Number of refugees of Swaziland in 2008 to that in 2014?
Provide a succinct answer. 1.5. What is the ratio of the Number of refugees of Chad in 2009 to that in 2010?
Give a very brief answer. 0.97. What is the ratio of the Number of refugees in Estonia in 2009 to that in 2010?
Offer a terse response. 0.62. What is the ratio of the Number of refugees of Chad in 2009 to that in 2011?
Your response must be concise. 0.92. What is the ratio of the Number of refugees in Estonia in 2009 to that in 2011?
Provide a succinct answer. 0.48. What is the ratio of the Number of refugees of Panama in 2009 to that in 2011?
Give a very brief answer. 0.98. What is the ratio of the Number of refugees in Swaziland in 2009 to that in 2011?
Provide a short and direct response. 1. What is the ratio of the Number of refugees of Chad in 2009 to that in 2012?
Offer a terse response. 0.91. What is the ratio of the Number of refugees in Estonia in 2009 to that in 2012?
Provide a succinct answer. 0.38. What is the ratio of the Number of refugees in Swaziland in 2009 to that in 2012?
Ensure brevity in your answer.  1.5. What is the ratio of the Number of refugees of Chad in 2009 to that in 2013?
Offer a very short reply. 0.78. What is the ratio of the Number of refugees of Estonia in 2009 to that in 2013?
Provide a succinct answer. 0.34. What is the ratio of the Number of refugees of Panama in 2009 to that in 2013?
Make the answer very short. 0.96. What is the ratio of the Number of refugees of Swaziland in 2009 to that in 2013?
Keep it short and to the point. 1.5. What is the ratio of the Number of refugees of Chad in 2009 to that in 2014?
Provide a short and direct response. 0.75. What is the ratio of the Number of refugees in Estonia in 2009 to that in 2014?
Offer a terse response. 0.27. What is the ratio of the Number of refugees of Panama in 2009 to that in 2014?
Provide a short and direct response. 7.45. What is the ratio of the Number of refugees in Swaziland in 2009 to that in 2014?
Your response must be concise. 1.47. What is the ratio of the Number of refugees in Chad in 2010 to that in 2011?
Make the answer very short. 0.95. What is the ratio of the Number of refugees in Estonia in 2010 to that in 2011?
Your response must be concise. 0.78. What is the ratio of the Number of refugees in Panama in 2010 to that in 2011?
Keep it short and to the point. 0.99. What is the ratio of the Number of refugees in Chad in 2010 to that in 2012?
Your answer should be very brief. 0.93. What is the ratio of the Number of refugees of Estonia in 2010 to that in 2012?
Provide a short and direct response. 0.62. What is the ratio of the Number of refugees of Panama in 2010 to that in 2012?
Keep it short and to the point. 0.98. What is the ratio of the Number of refugees of Swaziland in 2010 to that in 2012?
Ensure brevity in your answer.  1.5. What is the ratio of the Number of refugees in Chad in 2010 to that in 2013?
Provide a succinct answer. 0.8. What is the ratio of the Number of refugees in Estonia in 2010 to that in 2013?
Give a very brief answer. 0.56. What is the ratio of the Number of refugees in Panama in 2010 to that in 2013?
Provide a succinct answer. 0.97. What is the ratio of the Number of refugees of Swaziland in 2010 to that in 2013?
Your answer should be compact. 1.5. What is the ratio of the Number of refugees in Chad in 2010 to that in 2014?
Provide a short and direct response. 0.77. What is the ratio of the Number of refugees of Estonia in 2010 to that in 2014?
Provide a succinct answer. 0.43. What is the ratio of the Number of refugees of Panama in 2010 to that in 2014?
Give a very brief answer. 7.52. What is the ratio of the Number of refugees in Swaziland in 2010 to that in 2014?
Keep it short and to the point. 1.47. What is the ratio of the Number of refugees in Chad in 2011 to that in 2012?
Ensure brevity in your answer.  0.98. What is the ratio of the Number of refugees in Estonia in 2011 to that in 2012?
Your answer should be very brief. 0.79. What is the ratio of the Number of refugees of Panama in 2011 to that in 2012?
Ensure brevity in your answer.  0.99. What is the ratio of the Number of refugees of Swaziland in 2011 to that in 2012?
Your answer should be compact. 1.5. What is the ratio of the Number of refugees of Chad in 2011 to that in 2013?
Provide a succinct answer. 0.84. What is the ratio of the Number of refugees of Panama in 2011 to that in 2013?
Ensure brevity in your answer.  0.98. What is the ratio of the Number of refugees in Swaziland in 2011 to that in 2013?
Provide a succinct answer. 1.5. What is the ratio of the Number of refugees in Chad in 2011 to that in 2014?
Keep it short and to the point. 0.81. What is the ratio of the Number of refugees in Estonia in 2011 to that in 2014?
Your answer should be compact. 0.56. What is the ratio of the Number of refugees in Panama in 2011 to that in 2014?
Give a very brief answer. 7.6. What is the ratio of the Number of refugees of Swaziland in 2011 to that in 2014?
Your answer should be compact. 1.47. What is the ratio of the Number of refugees of Chad in 2012 to that in 2013?
Provide a short and direct response. 0.86. What is the ratio of the Number of refugees of Estonia in 2012 to that in 2013?
Make the answer very short. 0.9. What is the ratio of the Number of refugees of Panama in 2012 to that in 2013?
Your answer should be very brief. 0.99. What is the ratio of the Number of refugees in Chad in 2012 to that in 2014?
Your answer should be compact. 0.83. What is the ratio of the Number of refugees of Estonia in 2012 to that in 2014?
Your answer should be compact. 0.7. What is the ratio of the Number of refugees of Panama in 2012 to that in 2014?
Keep it short and to the point. 7.67. What is the ratio of the Number of refugees of Swaziland in 2012 to that in 2014?
Offer a terse response. 0.98. What is the ratio of the Number of refugees of Chad in 2013 to that in 2014?
Give a very brief answer. 0.96. What is the ratio of the Number of refugees of Estonia in 2013 to that in 2014?
Provide a succinct answer. 0.78. What is the ratio of the Number of refugees of Panama in 2013 to that in 2014?
Your response must be concise. 7.78. What is the ratio of the Number of refugees of Swaziland in 2013 to that in 2014?
Make the answer very short. 0.98. What is the difference between the highest and the second highest Number of refugees of Chad?
Your answer should be compact. 1.84e+04. What is the difference between the highest and the second highest Number of refugees in Panama?
Your answer should be compact. 236. What is the difference between the highest and the second highest Number of refugees of Swaziland?
Offer a terse response. 16. What is the difference between the highest and the lowest Number of refugees of Chad?
Your answer should be very brief. 1.22e+05. What is the difference between the highest and the lowest Number of refugees of Estonia?
Keep it short and to the point. 68. What is the difference between the highest and the lowest Number of refugees in Panama?
Your response must be concise. 1.54e+04. What is the difference between the highest and the lowest Number of refugees of Swaziland?
Provide a succinct answer. 270. 